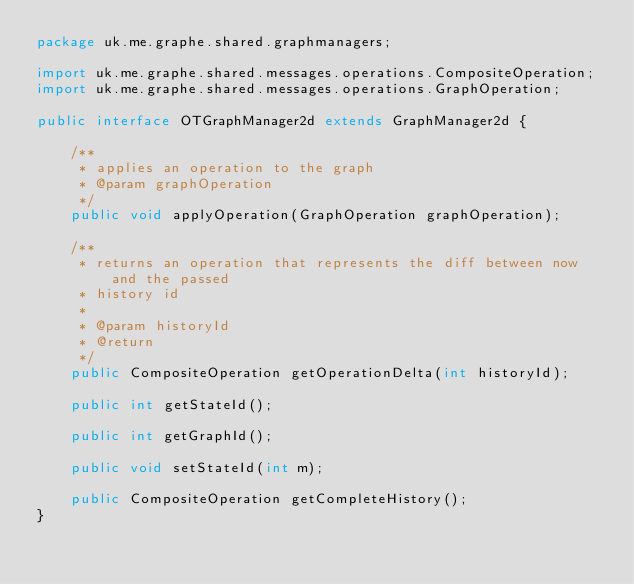Convert code to text. <code><loc_0><loc_0><loc_500><loc_500><_Java_>package uk.me.graphe.shared.graphmanagers;

import uk.me.graphe.shared.messages.operations.CompositeOperation;
import uk.me.graphe.shared.messages.operations.GraphOperation;

public interface OTGraphManager2d extends GraphManager2d {

    /**
     * applies an operation to the graph
     * @param graphOperation
     */
    public void applyOperation(GraphOperation graphOperation);

    /**
     * returns an operation that represents the diff between now and the passed
     * history id
     * 
     * @param historyId
     * @return
     */
    public CompositeOperation getOperationDelta(int historyId);

    public int getStateId();

    public int getGraphId();
    
    public void setStateId(int m);
    
    public CompositeOperation getCompleteHistory();
}
</code> 